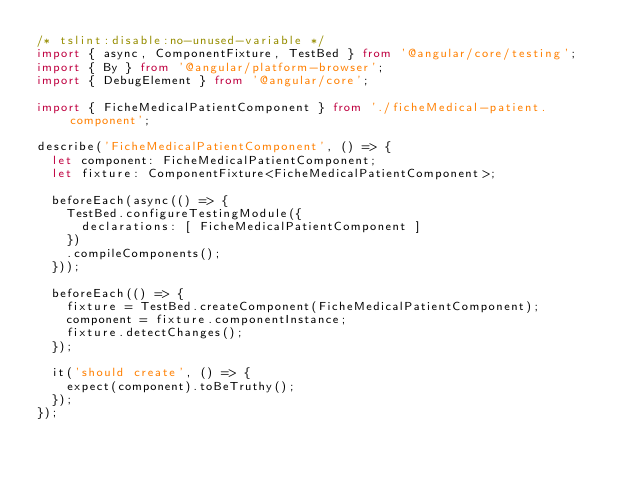<code> <loc_0><loc_0><loc_500><loc_500><_TypeScript_>/* tslint:disable:no-unused-variable */
import { async, ComponentFixture, TestBed } from '@angular/core/testing';
import { By } from '@angular/platform-browser';
import { DebugElement } from '@angular/core';

import { FicheMedicalPatientComponent } from './ficheMedical-patient.component';

describe('FicheMedicalPatientComponent', () => {
  let component: FicheMedicalPatientComponent;
  let fixture: ComponentFixture<FicheMedicalPatientComponent>;

  beforeEach(async(() => {
    TestBed.configureTestingModule({
      declarations: [ FicheMedicalPatientComponent ]
    })
    .compileComponents();
  }));

  beforeEach(() => {
    fixture = TestBed.createComponent(FicheMedicalPatientComponent);
    component = fixture.componentInstance;
    fixture.detectChanges();
  });

  it('should create', () => {
    expect(component).toBeTruthy();
  });
});
</code> 